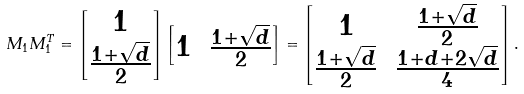Convert formula to latex. <formula><loc_0><loc_0><loc_500><loc_500>M _ { 1 } M _ { 1 } ^ { T } = \begin{bmatrix} 1 \\ \frac { 1 + \sqrt { d } } { 2 } \end{bmatrix} \begin{bmatrix} 1 & \frac { 1 + \sqrt { d } } { 2 } \end{bmatrix} = \begin{bmatrix} 1 & \frac { 1 + \sqrt { d } } { 2 } \\ \frac { 1 + \sqrt { d } } { 2 } & \frac { 1 + d + 2 \sqrt { d } } { 4 } \end{bmatrix} .</formula> 